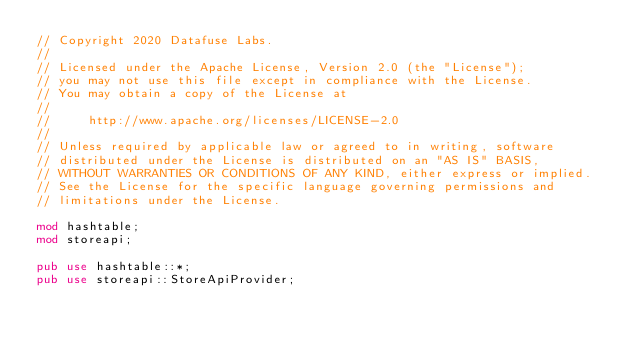Convert code to text. <code><loc_0><loc_0><loc_500><loc_500><_Rust_>// Copyright 2020 Datafuse Labs.
//
// Licensed under the Apache License, Version 2.0 (the "License");
// you may not use this file except in compliance with the License.
// You may obtain a copy of the License at
//
//     http://www.apache.org/licenses/LICENSE-2.0
//
// Unless required by applicable law or agreed to in writing, software
// distributed under the License is distributed on an "AS IS" BASIS,
// WITHOUT WARRANTIES OR CONDITIONS OF ANY KIND, either express or implied.
// See the License for the specific language governing permissions and
// limitations under the License.

mod hashtable;
mod storeapi;

pub use hashtable::*;
pub use storeapi::StoreApiProvider;
</code> 